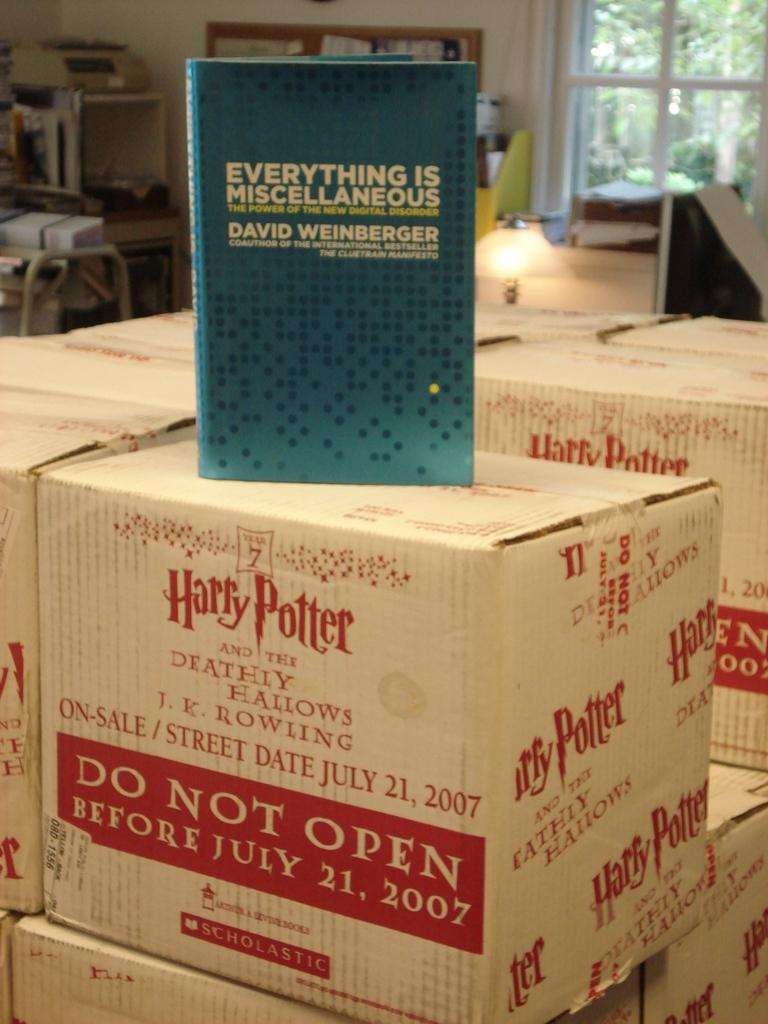<image>
Give a short and clear explanation of the subsequent image. Multiple boxes of Harry Potter and the Deathly Hallows are stacked together. 